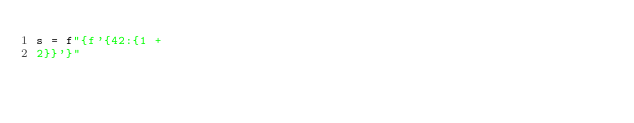<code> <loc_0><loc_0><loc_500><loc_500><_Python_>s = f"{f'{42:{1 +
2}}'}"</code> 